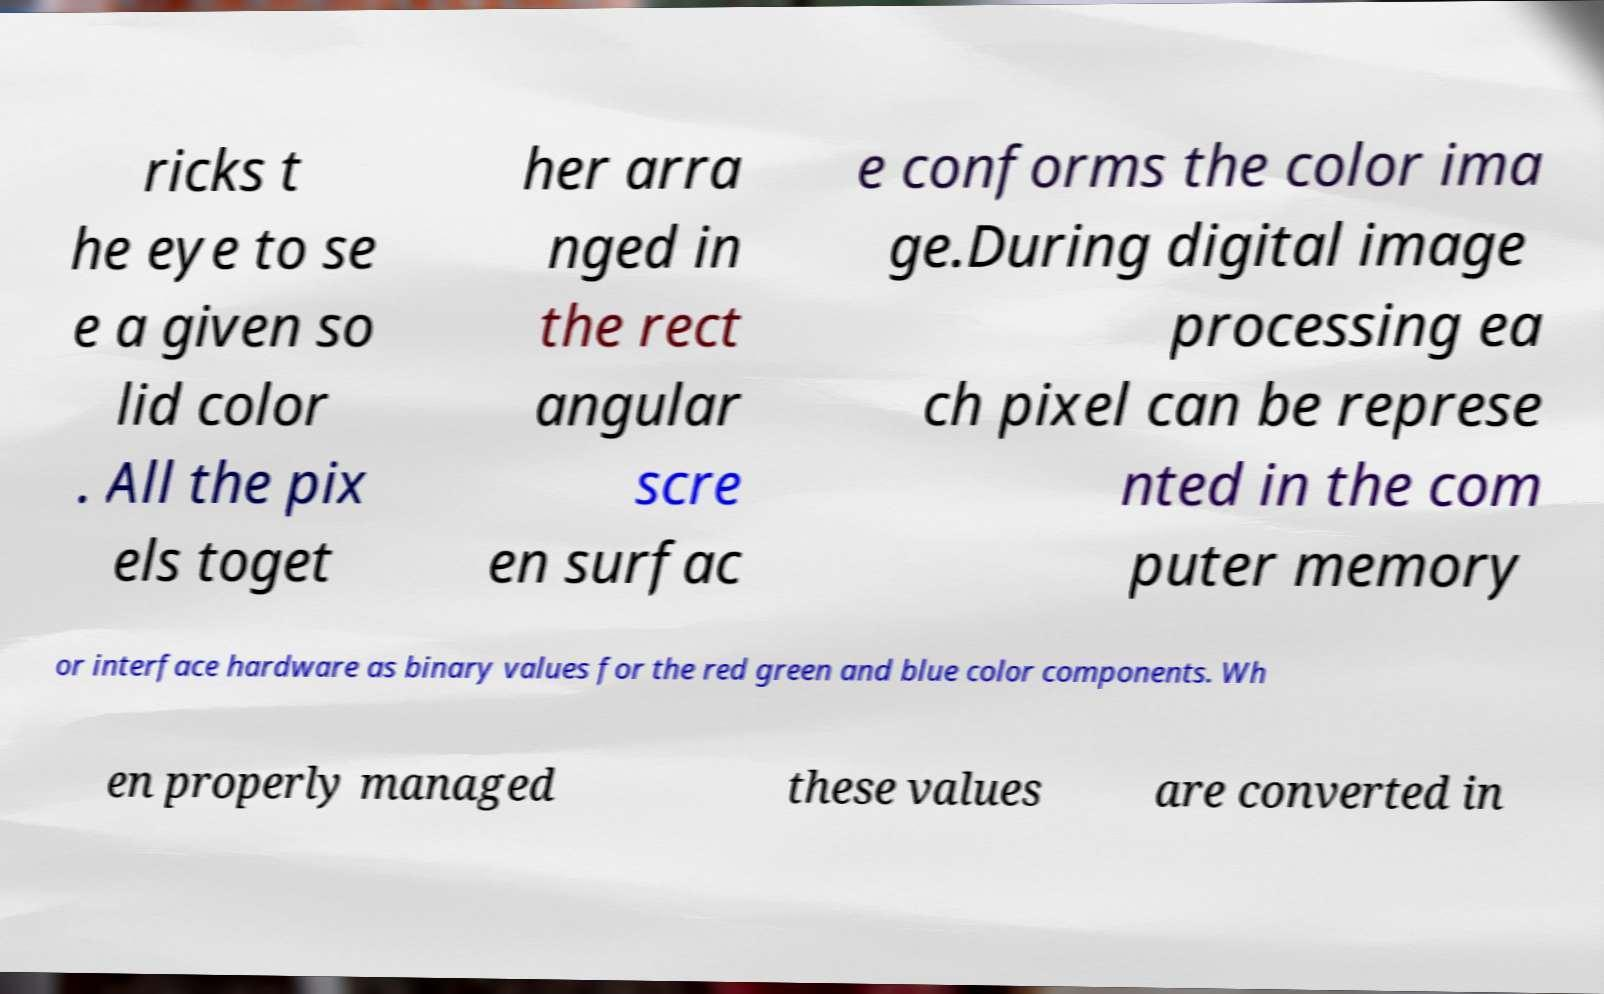Please read and relay the text visible in this image. What does it say? ricks t he eye to se e a given so lid color . All the pix els toget her arra nged in the rect angular scre en surfac e conforms the color ima ge.During digital image processing ea ch pixel can be represe nted in the com puter memory or interface hardware as binary values for the red green and blue color components. Wh en properly managed these values are converted in 